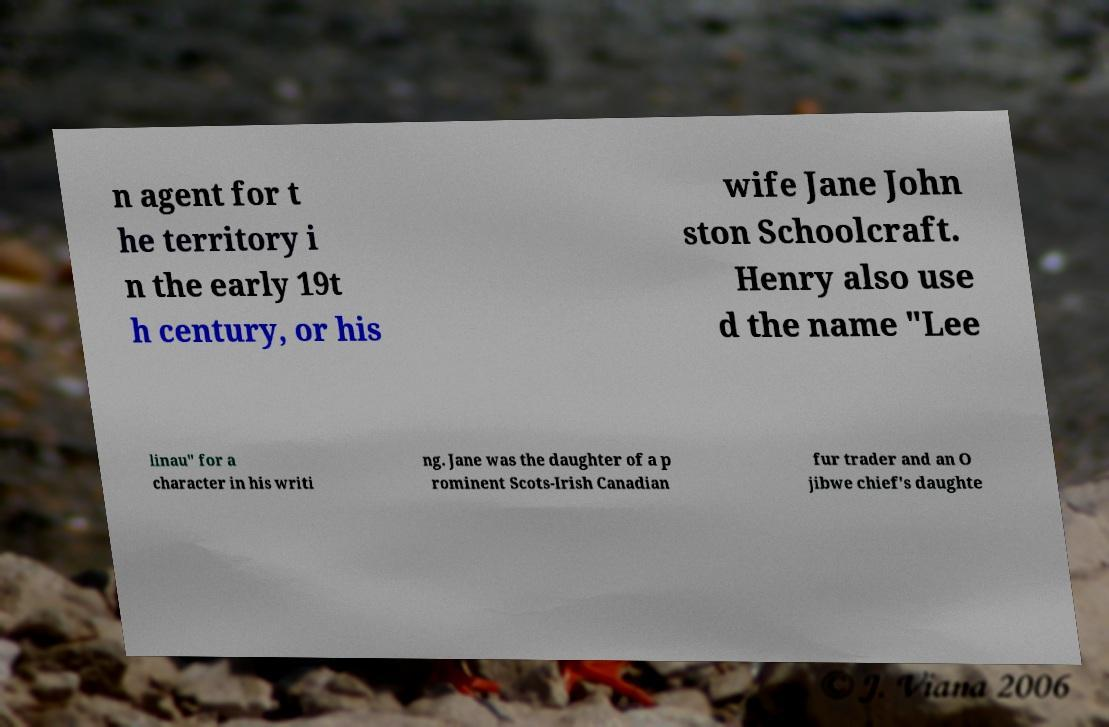Can you read and provide the text displayed in the image?This photo seems to have some interesting text. Can you extract and type it out for me? n agent for t he territory i n the early 19t h century, or his wife Jane John ston Schoolcraft. Henry also use d the name "Lee linau" for a character in his writi ng. Jane was the daughter of a p rominent Scots-Irish Canadian fur trader and an O jibwe chief's daughte 